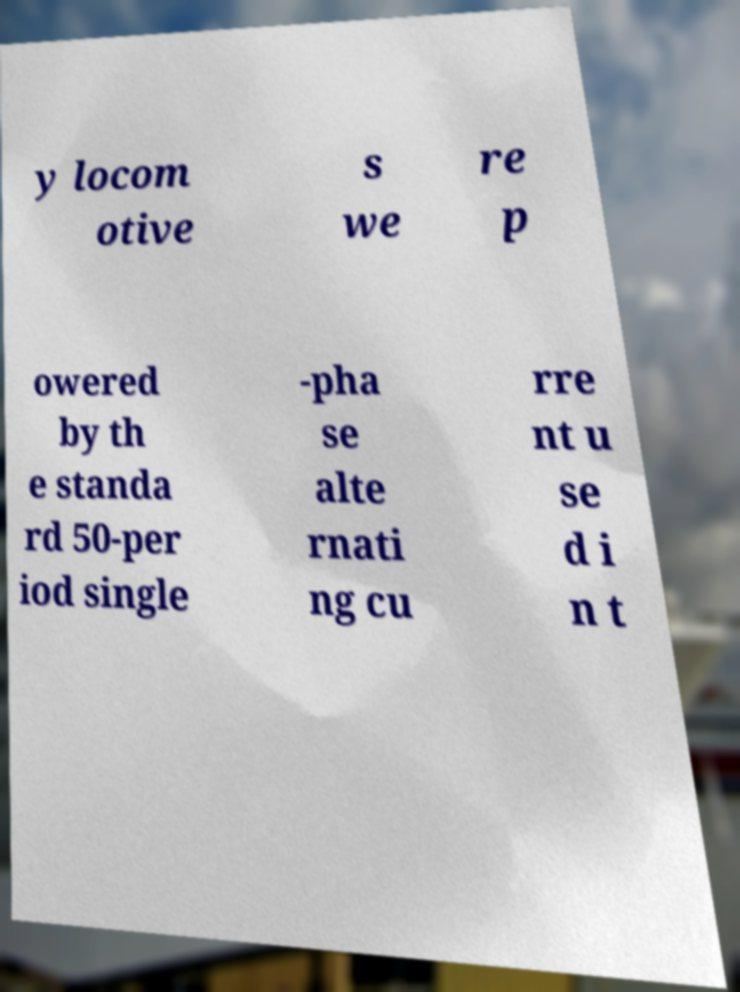Could you extract and type out the text from this image? y locom otive s we re p owered by th e standa rd 50-per iod single -pha se alte rnati ng cu rre nt u se d i n t 